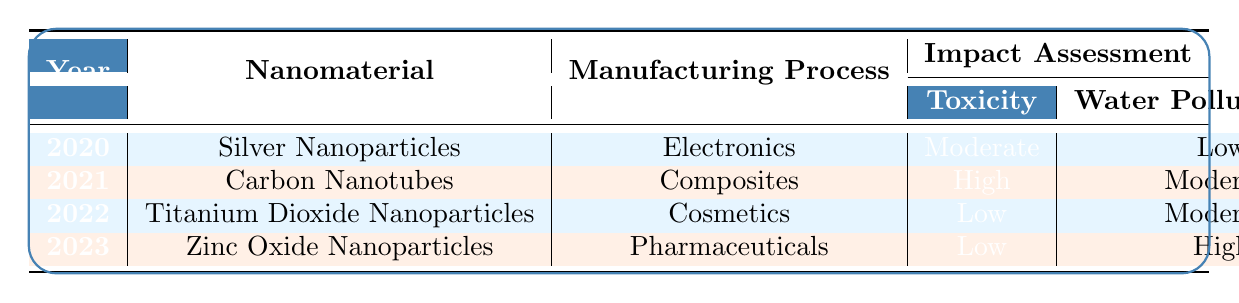What is the toxicity level of Silver Nanoparticles in 2020? From the table, we can see that the toxicity level of Silver Nanoparticles in the year 2020 is categorized as "Moderate".
Answer: Moderate Which nanomaterial had the highest air quality impact and in what year? Looking through the table, Carbon Nanotubes in 2021 has the highest air quality impact, which is classified as "High".
Answer: Carbon Nanotubes, 2021 Did any nanomaterial show a reduced energy consumption in its manufacturing process? By checking the energy consumption column, we can note that both Silver Nanoparticles in 2020 (Reduced by 15%) and Titanium Dioxide Nanoparticles in 2022 (Reduced by 5%) show a reduction in energy consumption.
Answer: Yes, Silver Nanoparticles and Titanium Dioxide Nanoparticles What is the water pollution risk associated with Zinc Oxide Nanoparticles in 2023? From the table, it is clear that the water pollution risk for Zinc Oxide Nanoparticles in 2023 is categorized as "High".
Answer: High In which years did the manufacturing processes contribute to a moderate water pollution risk? The table shows that in both the year 2021 (Carbon Nanotubes) and 2022 (Titanium Dioxide Nanoparticles), the water pollution risk is categorized as "Moderate".
Answer: 2021 and 2022 What is the average toxicity level of the nanomaterials listed in the table? The toxicity levels are classified as follows: Silver Nanoparticles (Moderate), Carbon Nanotubes (High), Titanium Dioxide (Low), and Zinc Oxide (Low). We can approximate toxicity levels as numeric values: Moderate (2), High (3), Low (1), resulting in (2 + 3 + 1 + 1) / 4 = 1.75, which would be classified as Low.
Answer: Low Has any nanomaterial assessed in 2023 shown stable energy consumption? Yes, the table indicates that Zinc Oxide Nanoparticles assessed in 2023 show "Stable" energy consumption, confirming that it did not increase or decrease.
Answer: Yes Which manufacturing process resulted in the highest energy consumption increase? From the table, the manufacturing process for Carbon Nanotubes in 2021 resulted in the highest energy consumption increase, recorded as "Increased by 10%".
Answer: Carbon Nanotubes, 2021 How many nanomaterials had a low toxicity rating from 2020 to 2023? Upon reviewing the table, Titanium Dioxide Nanoparticles (2022) and Zinc Oxide Nanoparticles (2023) both have a toxicity rating classified as "Low", making it a total of two nanomaterials.
Answer: Two 